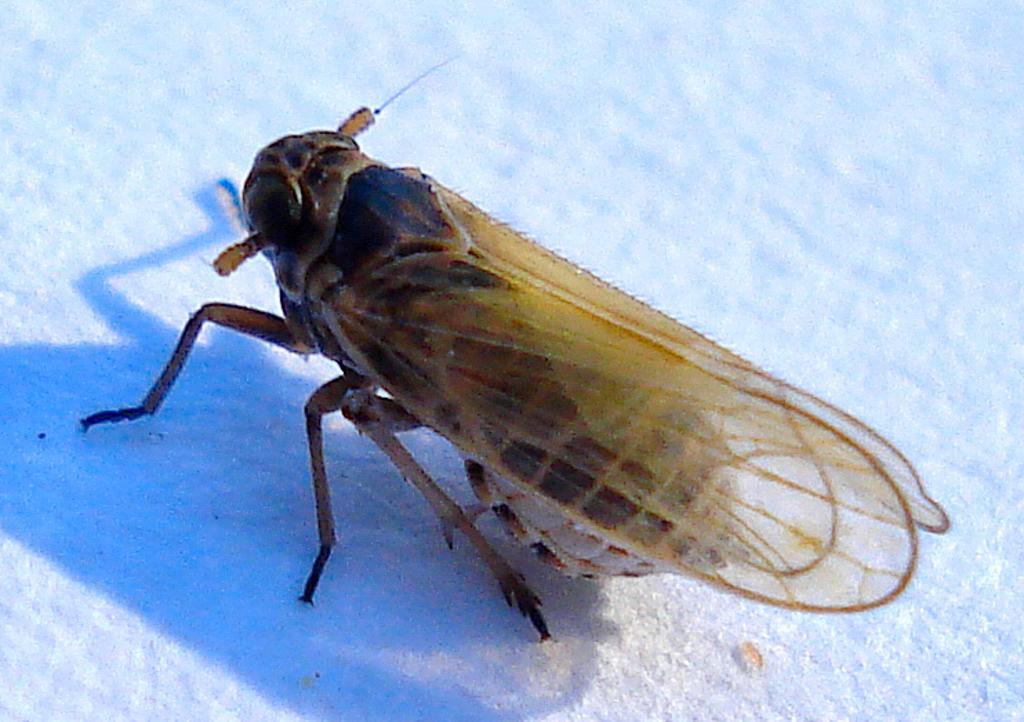Please provide a concise description of this image. This image is taken outdoors. In the background there is snow. In the middle of the image there is a fly on the snow. 